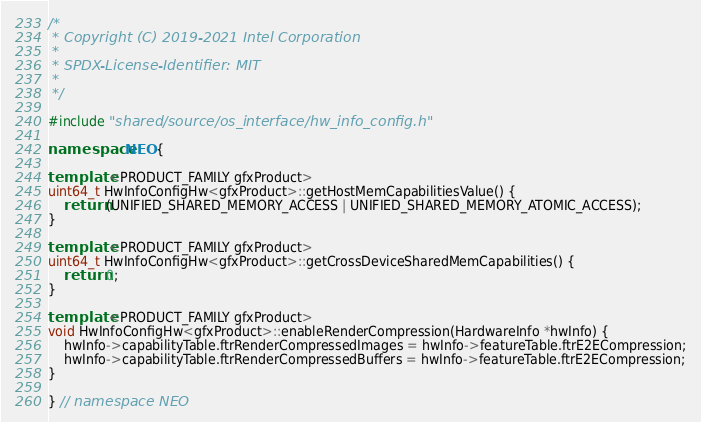Convert code to text. <code><loc_0><loc_0><loc_500><loc_500><_C++_>/*
 * Copyright (C) 2019-2021 Intel Corporation
 *
 * SPDX-License-Identifier: MIT
 *
 */

#include "shared/source/os_interface/hw_info_config.h"

namespace NEO {

template <PRODUCT_FAMILY gfxProduct>
uint64_t HwInfoConfigHw<gfxProduct>::getHostMemCapabilitiesValue() {
    return (UNIFIED_SHARED_MEMORY_ACCESS | UNIFIED_SHARED_MEMORY_ATOMIC_ACCESS);
}

template <PRODUCT_FAMILY gfxProduct>
uint64_t HwInfoConfigHw<gfxProduct>::getCrossDeviceSharedMemCapabilities() {
    return 0;
}

template <PRODUCT_FAMILY gfxProduct>
void HwInfoConfigHw<gfxProduct>::enableRenderCompression(HardwareInfo *hwInfo) {
    hwInfo->capabilityTable.ftrRenderCompressedImages = hwInfo->featureTable.ftrE2ECompression;
    hwInfo->capabilityTable.ftrRenderCompressedBuffers = hwInfo->featureTable.ftrE2ECompression;
}

} // namespace NEO
</code> 